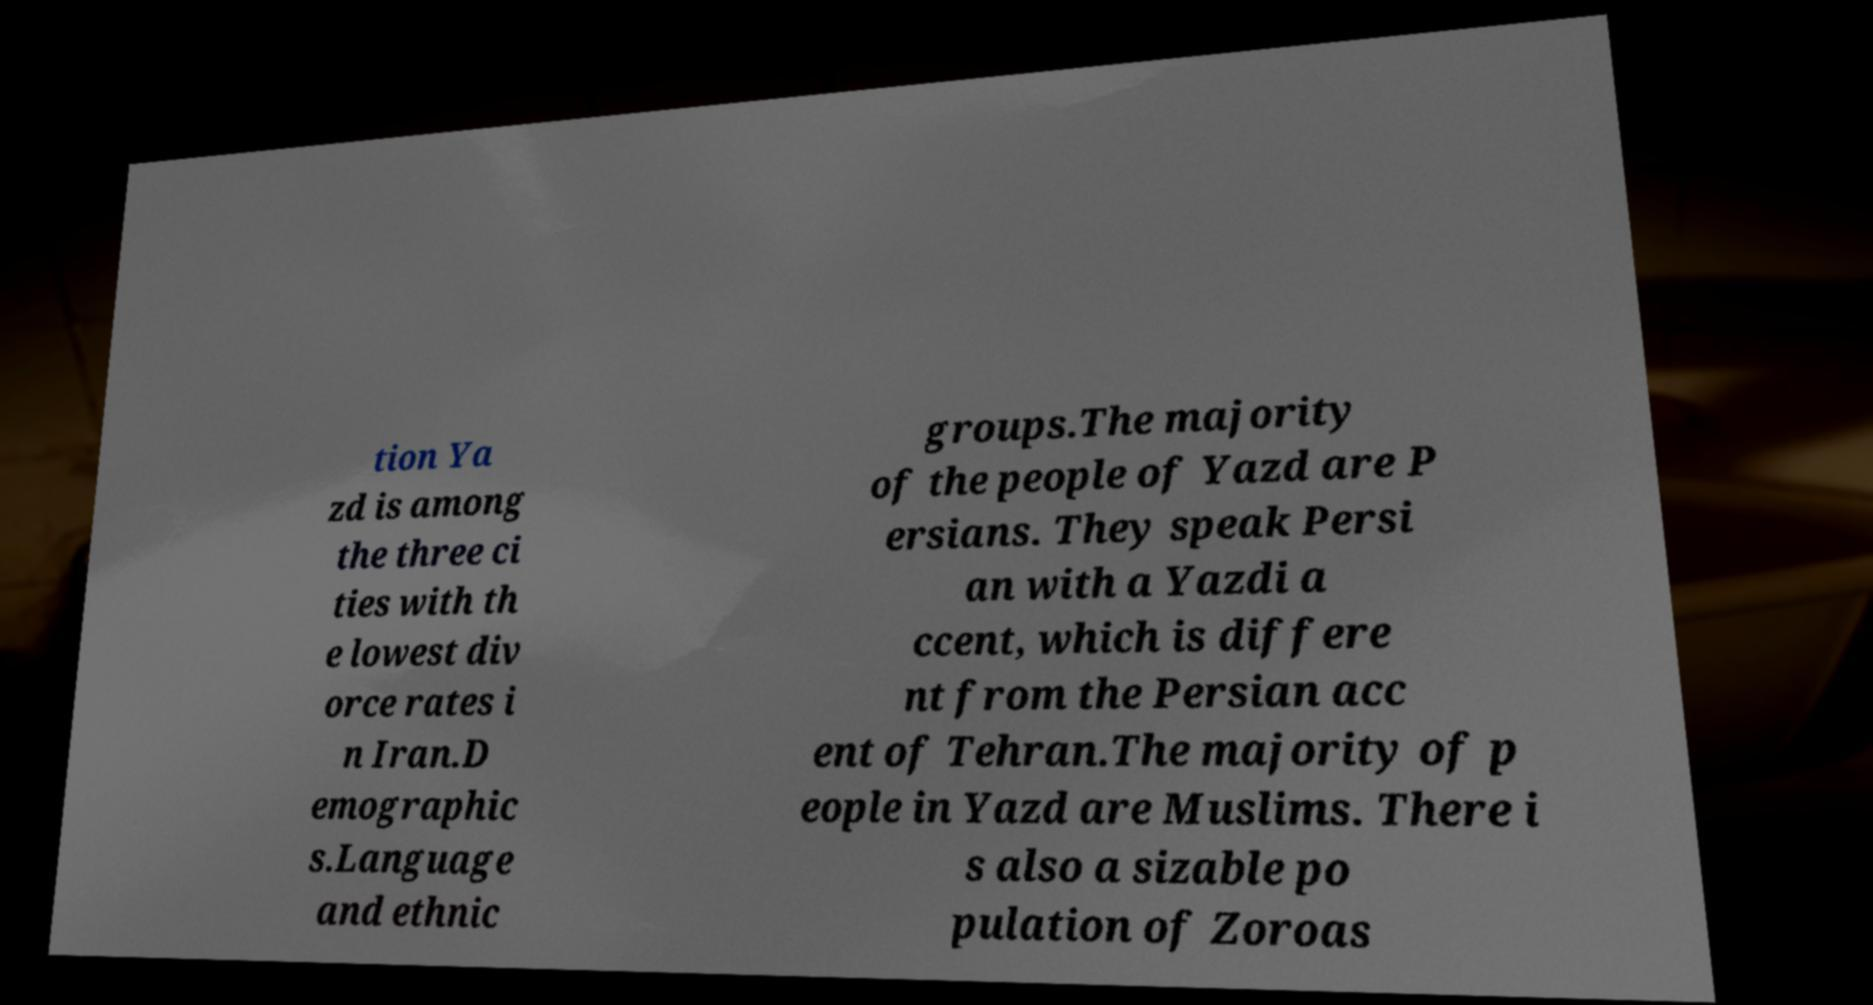Can you accurately transcribe the text from the provided image for me? tion Ya zd is among the three ci ties with th e lowest div orce rates i n Iran.D emographic s.Language and ethnic groups.The majority of the people of Yazd are P ersians. They speak Persi an with a Yazdi a ccent, which is differe nt from the Persian acc ent of Tehran.The majority of p eople in Yazd are Muslims. There i s also a sizable po pulation of Zoroas 